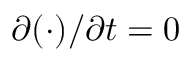<formula> <loc_0><loc_0><loc_500><loc_500>\partial ( \cdot ) / \partial t = 0</formula> 